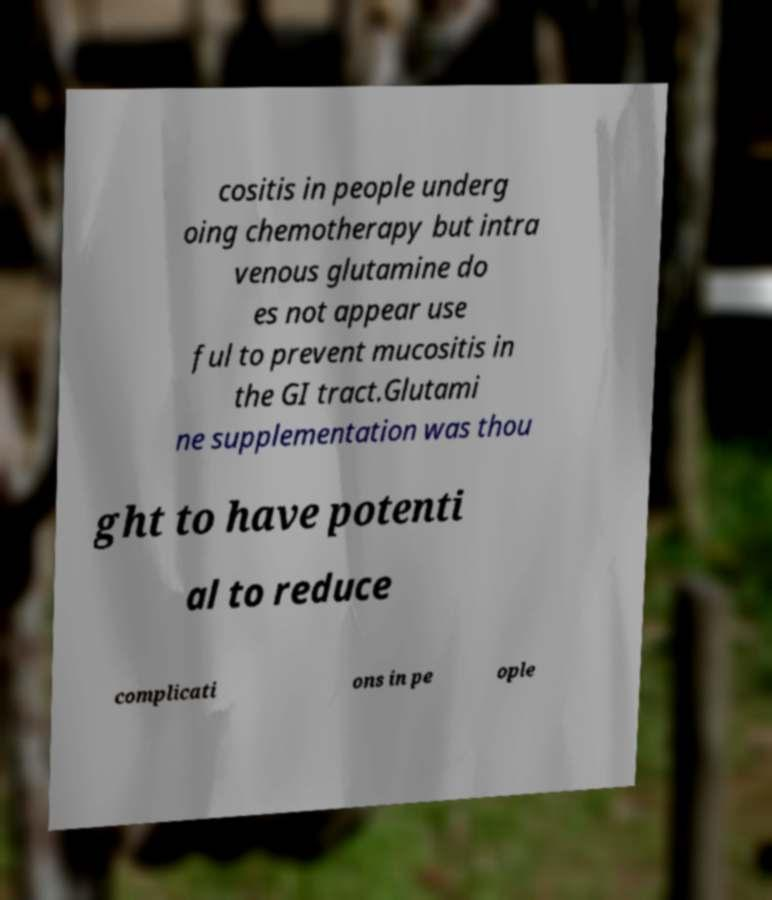Can you accurately transcribe the text from the provided image for me? cositis in people underg oing chemotherapy but intra venous glutamine do es not appear use ful to prevent mucositis in the GI tract.Glutami ne supplementation was thou ght to have potenti al to reduce complicati ons in pe ople 